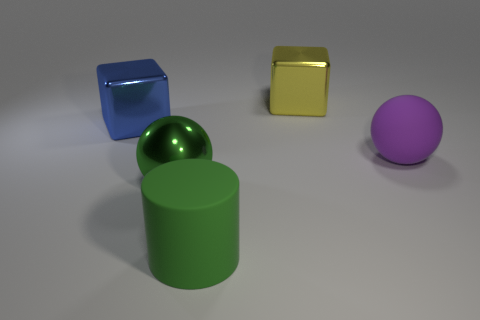Add 4 big blue objects. How many objects exist? 9 Subtract all blue cubes. How many cubes are left? 1 Subtract 2 blocks. How many blocks are left? 0 Add 5 big objects. How many big objects exist? 10 Subtract 0 purple blocks. How many objects are left? 5 Subtract all cylinders. How many objects are left? 4 Subtract all brown cubes. Subtract all blue cylinders. How many cubes are left? 2 Subtract all brown blocks. How many green balls are left? 1 Subtract all large blue metal blocks. Subtract all large green matte things. How many objects are left? 3 Add 4 big shiny things. How many big shiny things are left? 7 